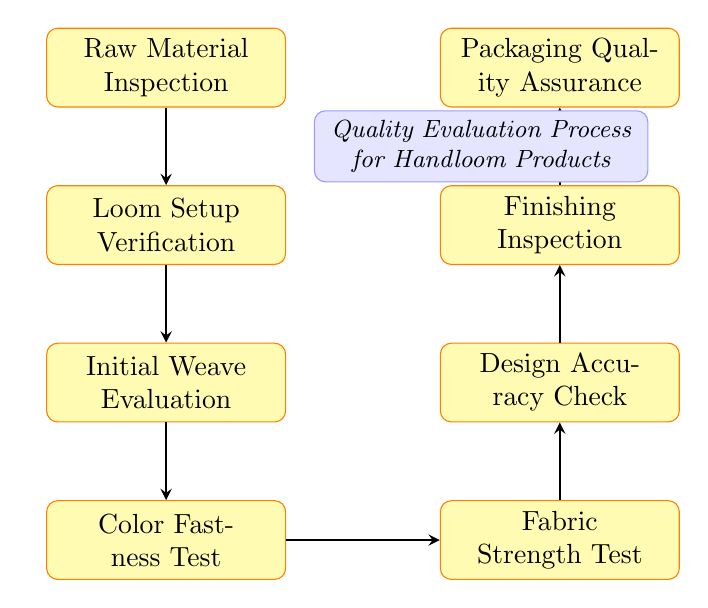What is the first step in the quality evaluation process? The first step is indicated at the top of the flow chart and is "Raw Material Inspection."
Answer: Raw Material Inspection How many total steps are there in the quality evaluation process? By counting the number of nodes in the flow chart, I find that there are eight distinct steps.
Answer: Eight What step comes after the "Initial Weave Evaluation"? The flow indicates that the next step after "Initial Weave Evaluation" is "Color Fastness Test."
Answer: Color Fastness Test Which step assesses the strength of the fabric? The flow chart specifies "Fabric Strength Test" as the step that focuses on evaluating the strength of the fabric.
Answer: Fabric Strength Test What are the last two steps in the evaluation process? The last two steps outlined in the flow are "Finishing Inspection" followed by "Packaging Quality Assurance."
Answer: Finishing Inspection and Packaging Quality Assurance In what position does "Design Accuracy Check" fall relative to "Fabric Strength Test"? By analyzing the diagram, I see that "Design Accuracy Check" is located above "Fabric Strength Test," indicating a sequential process.
Answer: Above What step verifies the loom settings? The diagram specifies "Loom Setup Verification" as the step that ensures the loom settings are correct.
Answer: Loom Setup Verification What is the relationship between "Color Fastness Test" and "Fabric Strength Test"? The relationship is that "Color Fastness Test" directly precedes "Fabric Strength Test" in the flow of the quality evaluation process.
Answer: Color Fastness Test comes before Fabric Strength Test 